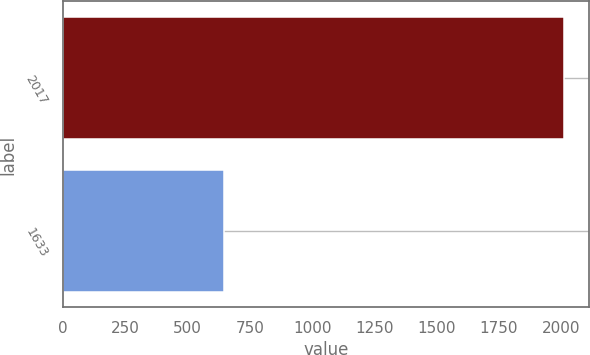Convert chart to OTSL. <chart><loc_0><loc_0><loc_500><loc_500><bar_chart><fcel>2017<fcel>1633<nl><fcel>2014<fcel>644<nl></chart> 